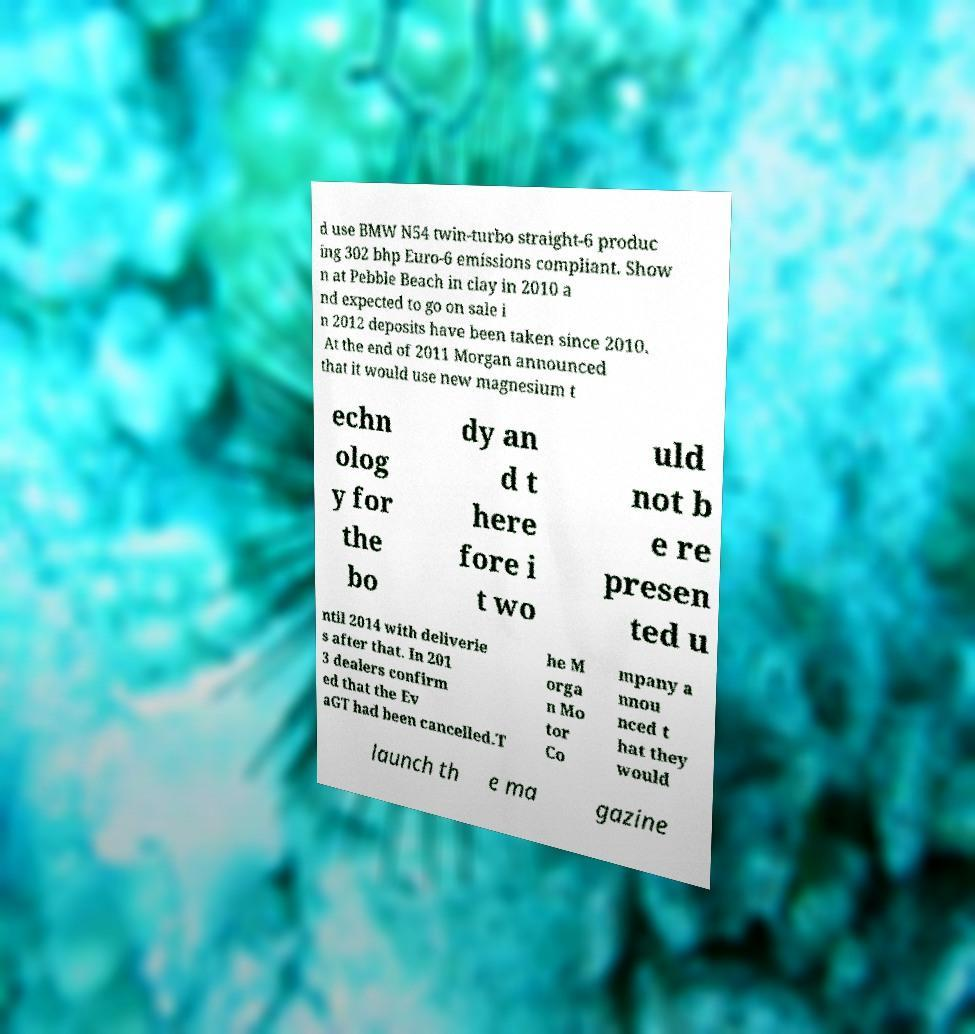I need the written content from this picture converted into text. Can you do that? d use BMW N54 twin-turbo straight-6 produc ing 302 bhp Euro-6 emissions compliant. Show n at Pebble Beach in clay in 2010 a nd expected to go on sale i n 2012 deposits have been taken since 2010. At the end of 2011 Morgan announced that it would use new magnesium t echn olog y for the bo dy an d t here fore i t wo uld not b e re presen ted u ntil 2014 with deliverie s after that. In 201 3 dealers confirm ed that the Ev aGT had been cancelled.T he M orga n Mo tor Co mpany a nnou nced t hat they would launch th e ma gazine 